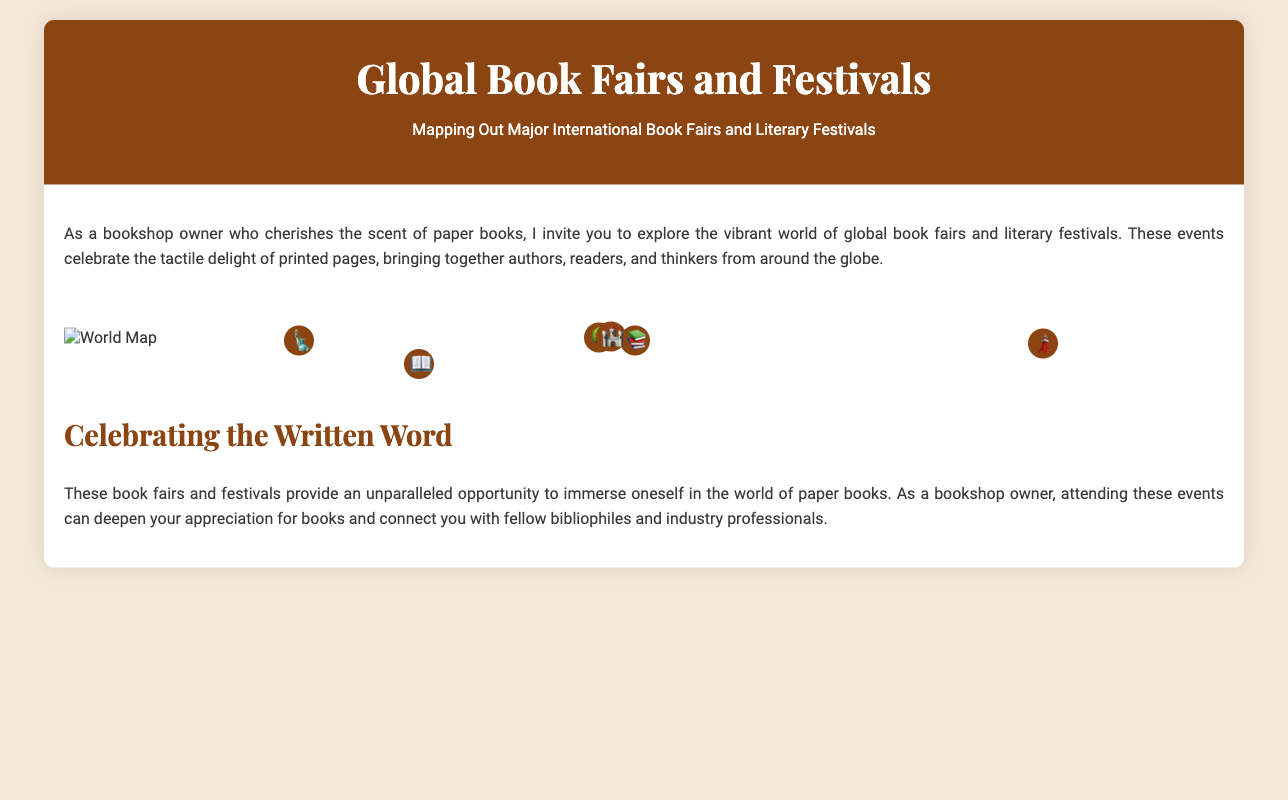What is the location of the Frankfurt Book Fair? The document states that the Frankfurt Book Fair is located in Frankfurt, Germany.
Answer: Frankfurt, Germany When does the Hay Festival take place? According to the infographic, the Hay Festival occurs between May and June.
Answer: May - June What cultural highlight is associated with the Buenos Aires International Book Fair? The document highlights that the Buenos Aires International Book Fair focuses on Latin American literature.
Answer: Latin American literature What is a key event during the Edinburgh International Book Festival? The document lists lectures and panels as key events during the Edinburgh International Book Festival.
Answer: Lectures and panels Which book fair features manga and anime exhibits? The Tokyo International Book Fair features manga and anime exhibits as mentioned in the document.
Answer: Tokyo International Book Fair What is the timeline for the Brooklyn Book Festival? The infographic specifies that the Brooklyn Book Festival occurs in September.
Answer: September How many countries are represented by the festivals mentioned in the infographic? The festivals listed in the document represent several countries, including Germany, Wales, Scotland, Argentina, Japan, and the USA, thus totaling six countries.
Answer: Six Which festival is set in a scenic countryside? The Hay Festival is noted for its focus on the scenic Welsh countryside in the document.
Answer: Hay Festival 